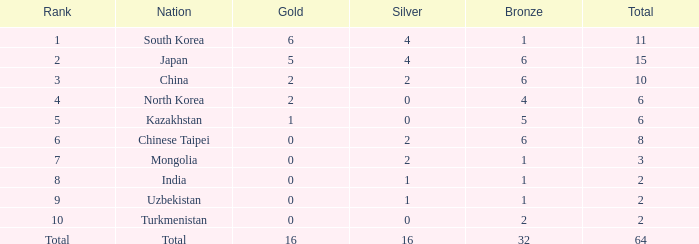What is the total Gold's less than 0? 0.0. 